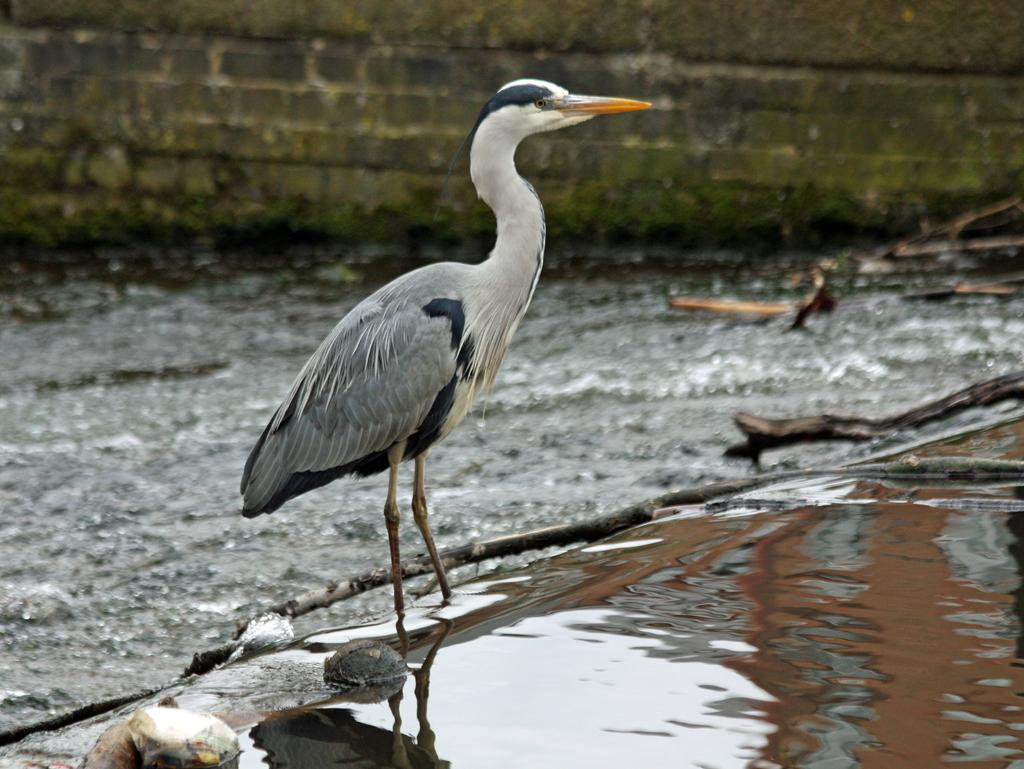What type of animal can be seen in the image? There is a bird in the image. What is the bird doing in the image? The bird is standing. What can be seen in the foreground of the image? There is water visible in the image. How would you describe the background of the image? The background of the image is slightly blurred, and the ground and a stone wall are visible. What type of square object can be seen in the bird's beak in the image? There is no square object present in the image, and the bird's beak is empty. What sound does the bird make in the image? The image is silent, so we cannot hear any sounds, including the bird's voice. 